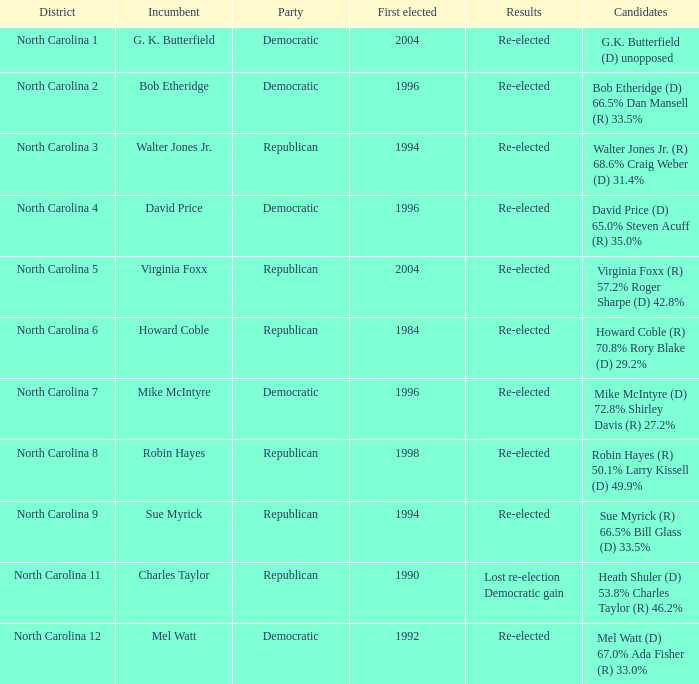Which party was elected first in 1998? Republican. 